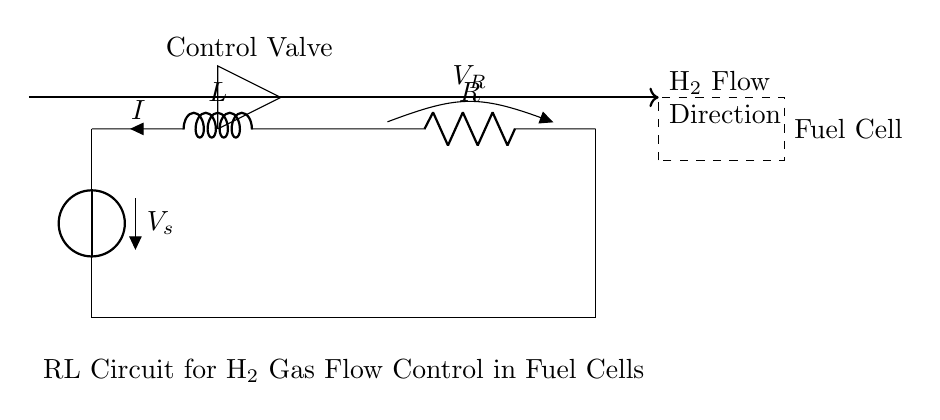What type of circuit is depicted? The circuit is an RL circuit, which consists of a resistor and an inductor connected in series with a voltage source.
Answer: RL circuit What controls the hydrogen flow? The control mechanism for hydrogen flow is represented by the control valve symbol drawn in the circuit.
Answer: Control valve What is indicated by the arrow in the circuit? The arrow indicates the direction of hydrogen gas flow, showing that it moves from left to right across the circuit.
Answer: H2 Flow Direction What is the voltage source labeled as? The voltage source in the circuit is labeled as V sub s, indicating it is the source of electrical potential driving the circuit.
Answer: V_s What happens to current in an RL circuit when the voltage is applied? When voltage is applied, the current starts at zero and increases exponentially over time, considering the inductive behavior of the inductor in the circuit.
Answer: Increases exponentially What does the dashed rectangle represent? The dashed rectangle represents the fuel cell, which is the load that will utilize the hydrogen flow controlled by the circuit.
Answer: Fuel Cell How does the resistor affect the circuit? The resistor limits the current flow in the RL circuit, helping to convert electrical energy into heat and thus regulate the current sent to the fuel cell.
Answer: Limits current flow 